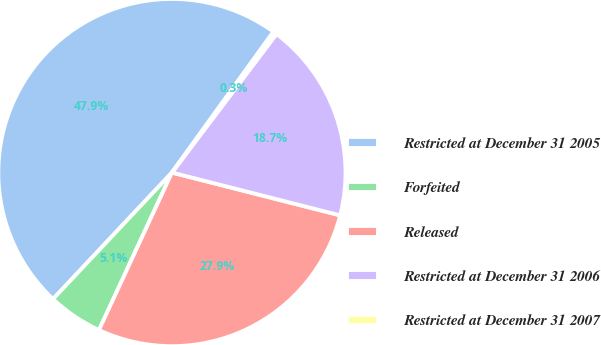Convert chart. <chart><loc_0><loc_0><loc_500><loc_500><pie_chart><fcel>Restricted at December 31 2005<fcel>Forfeited<fcel>Released<fcel>Restricted at December 31 2006<fcel>Restricted at December 31 2007<nl><fcel>47.94%<fcel>5.1%<fcel>27.94%<fcel>18.68%<fcel>0.34%<nl></chart> 